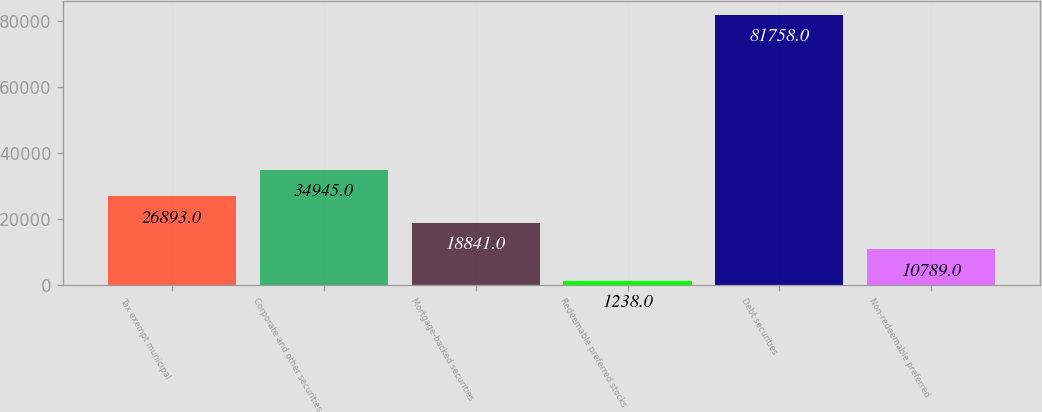Convert chart. <chart><loc_0><loc_0><loc_500><loc_500><bar_chart><fcel>Tax exempt municipal<fcel>Corporate and other securities<fcel>Mortgage-backed securities<fcel>Redeemable preferred stocks<fcel>Debt securities<fcel>Non-redeemable preferred<nl><fcel>26893<fcel>34945<fcel>18841<fcel>1238<fcel>81758<fcel>10789<nl></chart> 